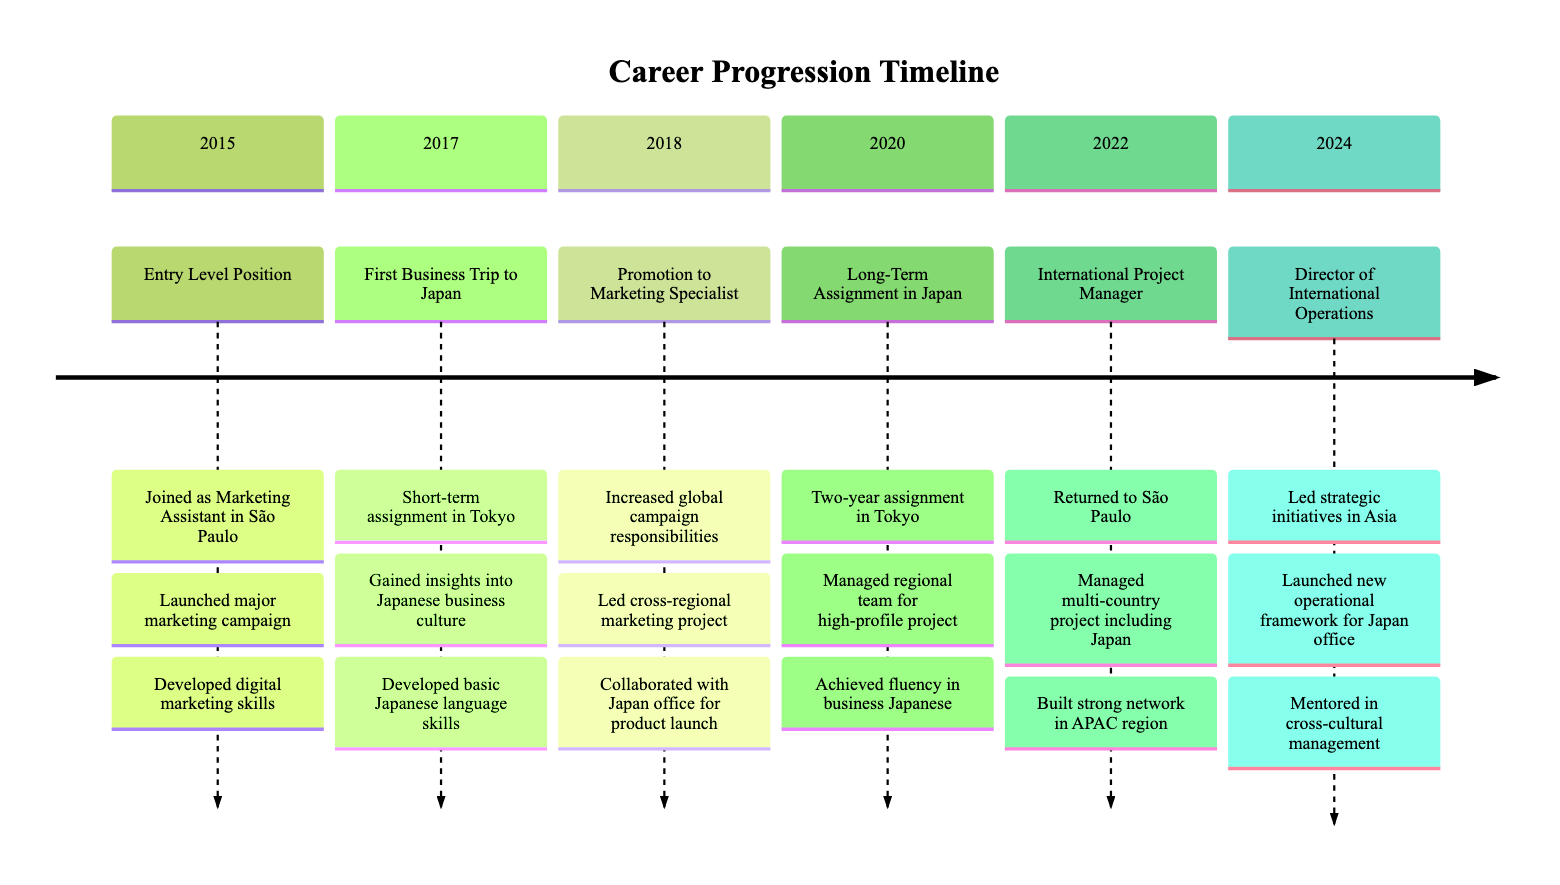What year did the individual start in the company? The timeline indicates that the individual joined the company in the year 2015 as a Marketing Assistant.
Answer: 2015 What was the role during the long-term assignment in Japan? In 2020, the individual was assigned as a Regional Team Manager during their long-term assignment in Japan.
Answer: Regional Team Manager How many key achievements are listed for the International Project Manager role? The timeline provides two key achievements for the International Project Manager role in 2022, which are successful project management and building a network in the APAC region.
Answer: Two Which position was achieved right after the First Business Trip to Japan? After the First Business Trip in 2017, the individual was promoted to Marketing Specialist in 2018.
Answer: Marketing Specialist What strategic initiatives did the individual lead as Director of International Operations? The Director of International Operations led the strategic initiatives in Asia, particularly launching a new operational framework for the Japan office in 2024.
Answer: New operational framework What notable skill was achieved during the Long-Term Assignment in Japan? The timeline states that fluency in business Japanese was achieved during the long-term assignment in Japan in 2020.
Answer: Fluency in business Japanese In what year did the individual initiate collaboration with the Japan office? The collaboration with the Japan office began in 2018 when the individual was promoted to Marketing Specialist.
Answer: 2018 How many years did the individual spend in the long-term assignment in Japan? The individual spent two years in the long-term assignment in Japan from 2020 to 2022.
Answer: Two years What was the first major achievement listed in 2015? The first major achievement listed in 2015 is that the individual assisted in the launch of a major marketing campaign.
Answer: Launched major marketing campaign 